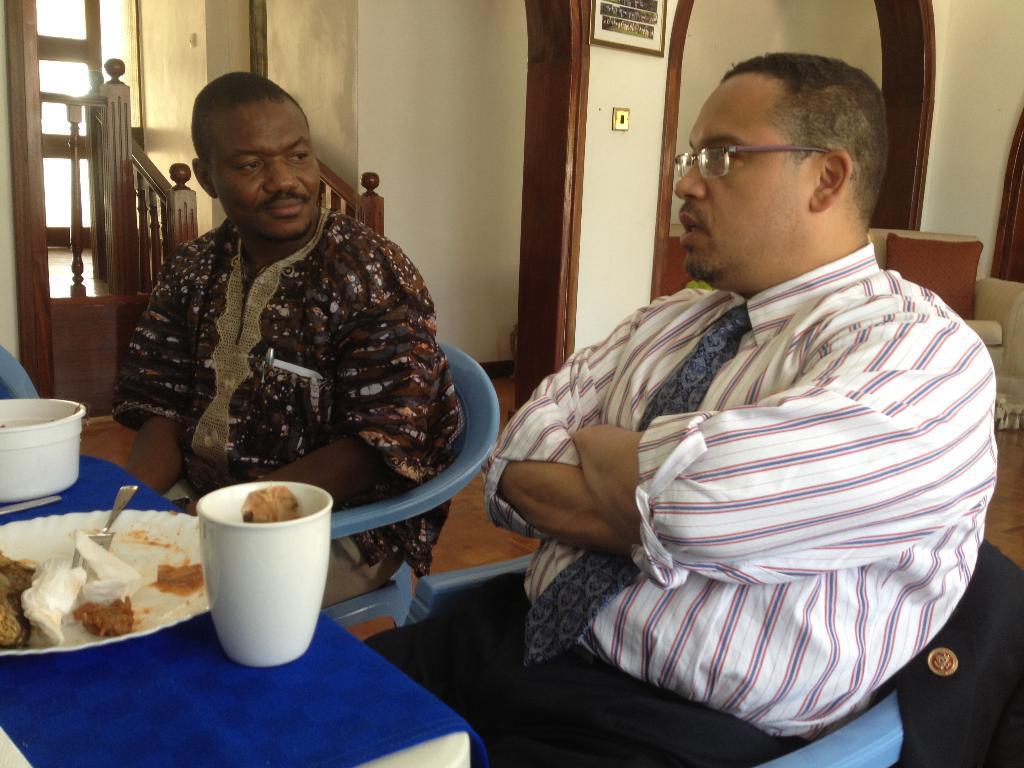In one or two sentences, can you explain what this image depicts? In this picture there are 2 persons sitting in the chair in table there is a food ,tissue, fork , plate , glass and at back ground there is a stair case , and a frame attached to wall ,and a couch with a pillow. 